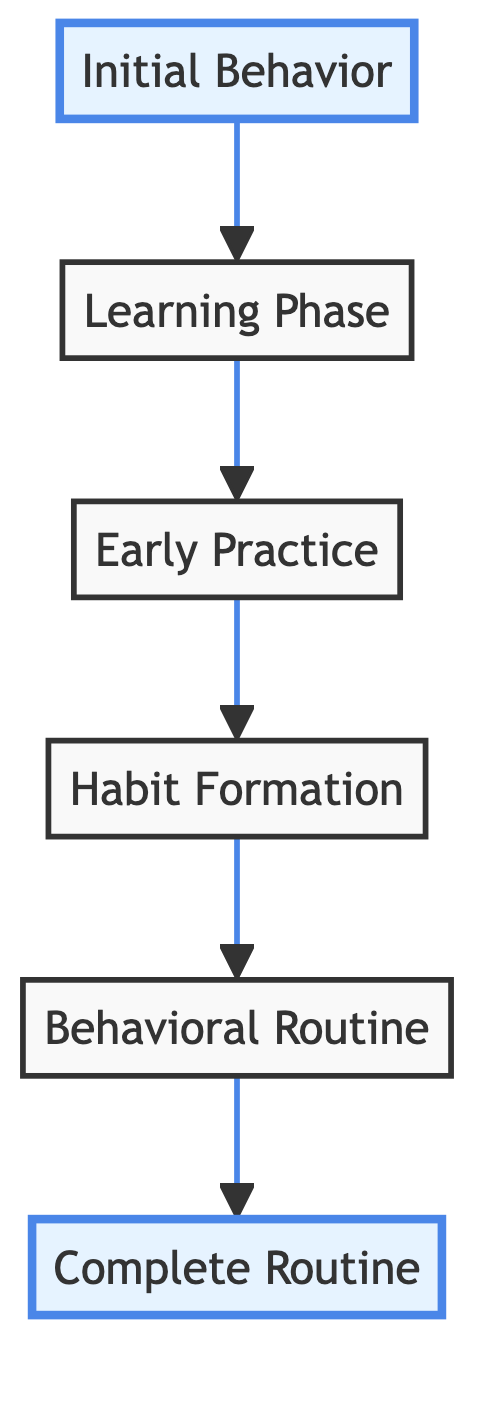What is the first stage of habit formation? The diagram specifies that the first stage, moving from bottom to top, is "Initial Behavior."
Answer: Initial Behavior How many total stages are there in the habit formation process? Counting all the stages from the bottom to the top in the diagram reveals six distinct stages.
Answer: Six Which stage comes after "Learning Phase"? Progressing through the diagram, it can be seen that the "Early Practice" stage follows the "Learning Phase."
Answer: Early Practice What behavior is typically observed during the "Habit Formation" stage? The diagram describes that during the "Habit Formation" stage, individuals start exercising three to four times a week and begin to see results.
Answer: Exercising three to four times a week and beginning to see initial results What is the final stage labeled in the diagram? As we look at the top of the diagram, the final stage in the habit formation process is labeled "Complete Routine."
Answer: Complete Routine What is the transition from "Habit Formation" to "Behavioral Routine"? The diagram indicates that individuals move from "Habit Formation," where they are regularly exercising, to "Behavioral Routine," where this behavior becomes automatic.
Answer: It becomes automatic In which stage does an individual actively learn the specifics of a new behavior? According to the diagram, this learning takes place during the "Learning Phase" stage.
Answer: Learning Phase What characterizes the "Behavioral Routine" stage compared to earlier stages? The diagram suggests that in the "Behavioral Routine," the behavior requires less cognitive effort compared to previous stages.
Answer: Requires less cognitive effort What type of reinforcement supports the "Complete Routine"? The diagram states that the "Complete Routine" is maintained by both intrinsic and extrinsic reinforcement.
Answer: Intrinsic and extrinsic reinforcement 